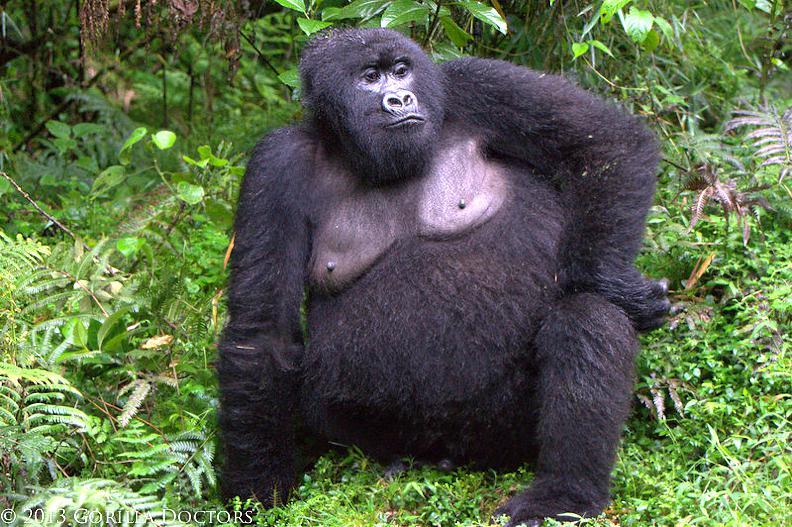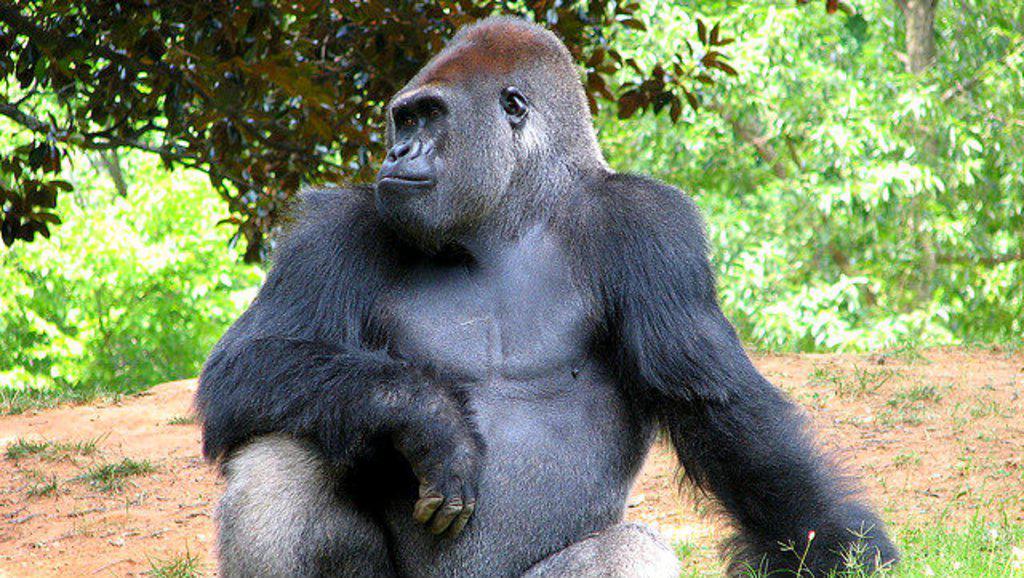The first image is the image on the left, the second image is the image on the right. Examine the images to the left and right. Is the description "A gorilla is eating a plant in one of the images." accurate? Answer yes or no. No. The first image is the image on the left, the second image is the image on the right. Assess this claim about the two images: "In at least one image, a large gorilla has its elbow bent and its hand raised towards its face.". Correct or not? Answer yes or no. No. 